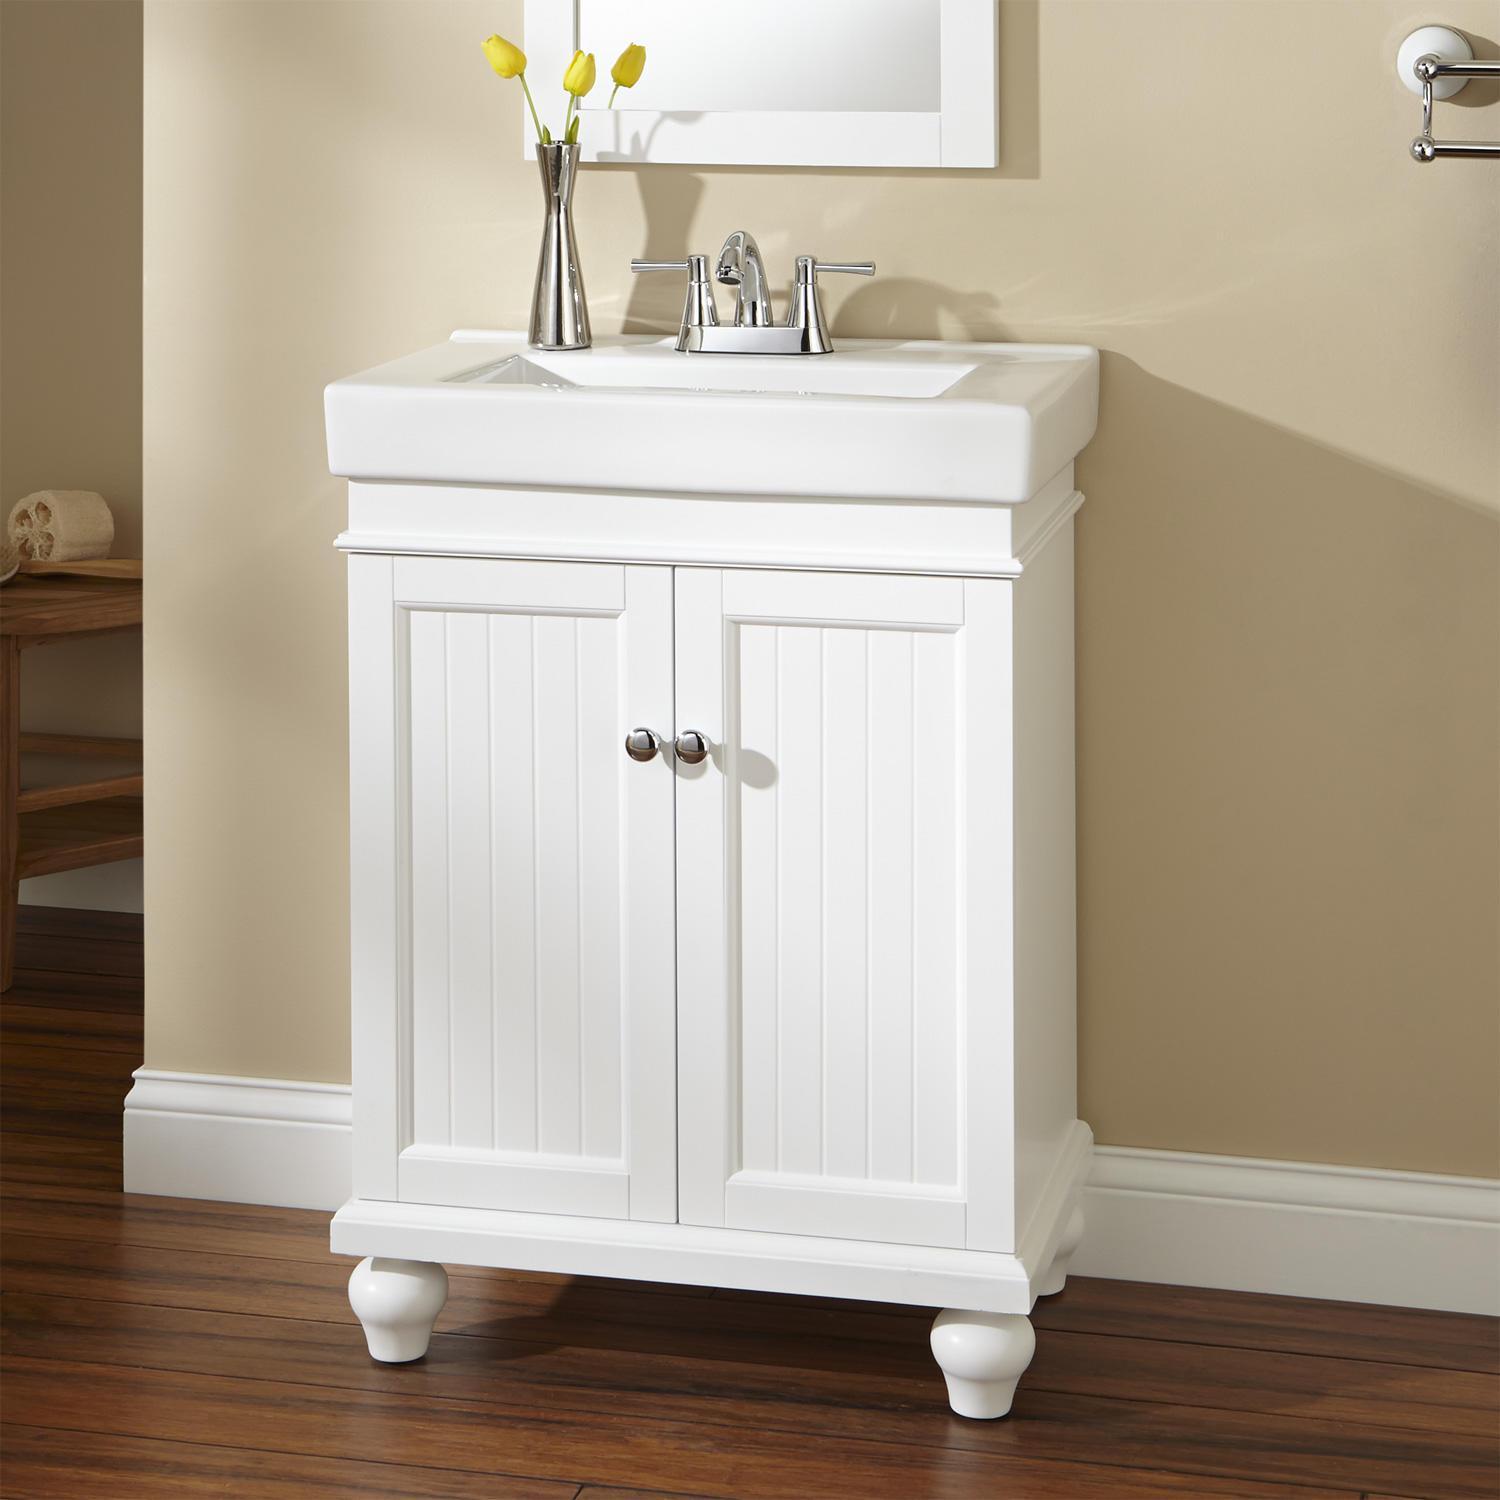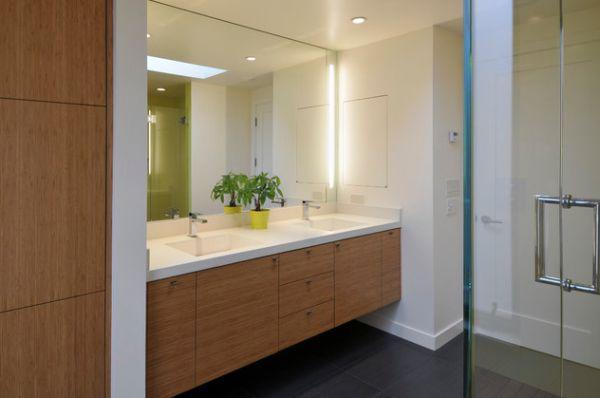The first image is the image on the left, the second image is the image on the right. For the images displayed, is the sentence "One image contains a single sink over a cabinet on short legs with double doors, and the other image includes a long vanity with two inset white rectangular sinks." factually correct? Answer yes or no. Yes. The first image is the image on the left, the second image is the image on the right. For the images displayed, is the sentence "In one image, a vanity the width of one sink has two doors and stands on short legs." factually correct? Answer yes or no. Yes. 